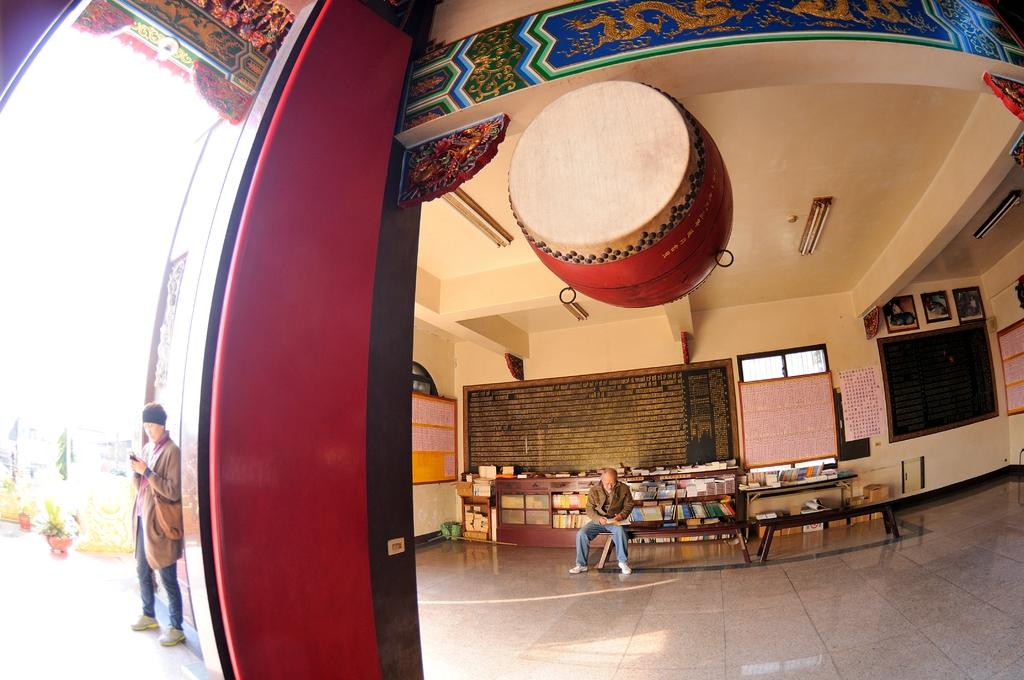What is the man in the image doing? There is a man standing in the image, and he is holding a mobile in his hand. Can you describe the other person in the image? There is another man seated on a bench in the image. What is unique about the seated man? The seated man has books on his back. How many bikes are parked next to the seated man in the image? There are no bikes present in the image. What type of mine is visible in the background of the image? There is no mine visible in the image. 